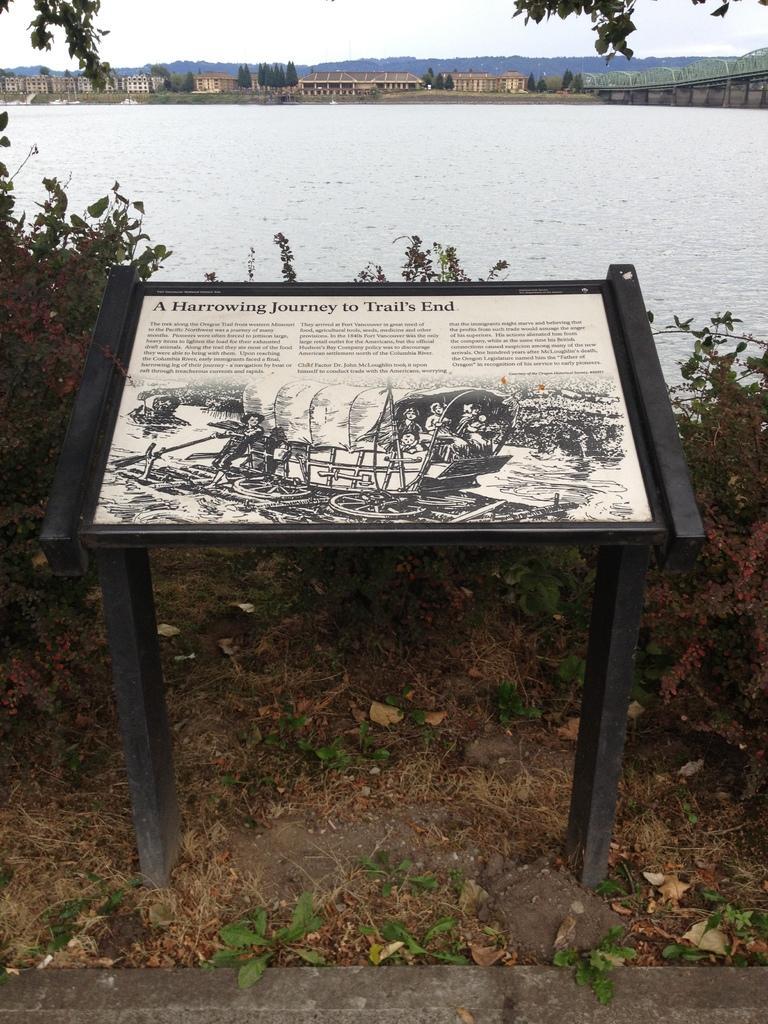Please provide a concise description of this image. There is a table. On the table we can see a poster. There are plants, water, houses, and trees. In the background there is sky. 